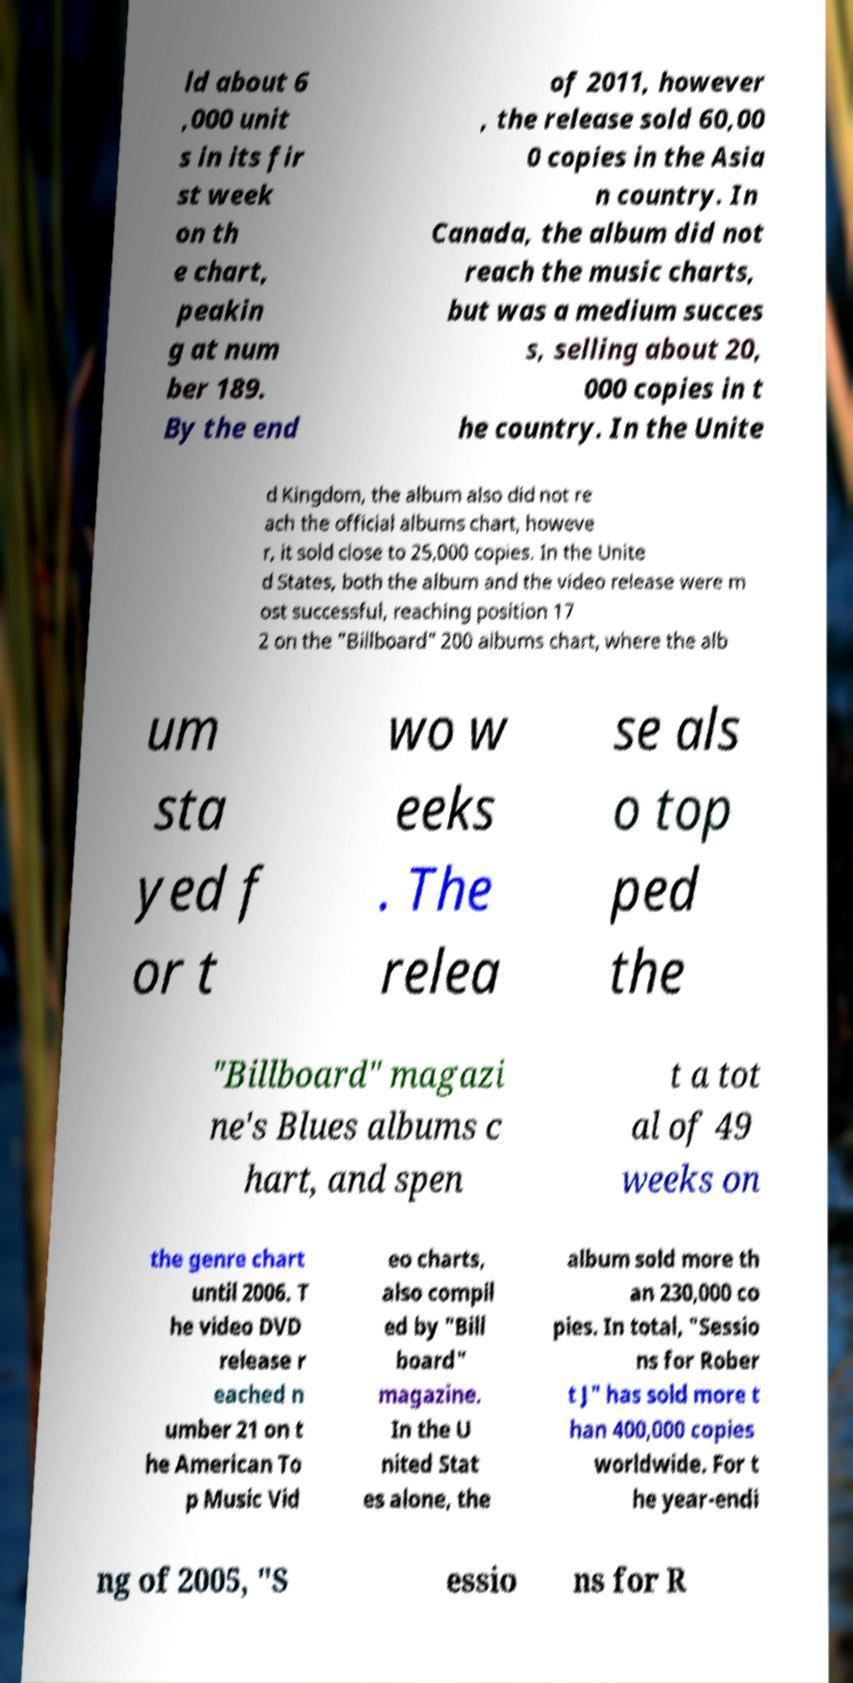Please read and relay the text visible in this image. What does it say? ld about 6 ,000 unit s in its fir st week on th e chart, peakin g at num ber 189. By the end of 2011, however , the release sold 60,00 0 copies in the Asia n country. In Canada, the album did not reach the music charts, but was a medium succes s, selling about 20, 000 copies in t he country. In the Unite d Kingdom, the album also did not re ach the official albums chart, howeve r, it sold close to 25,000 copies. In the Unite d States, both the album and the video release were m ost successful, reaching position 17 2 on the "Billboard" 200 albums chart, where the alb um sta yed f or t wo w eeks . The relea se als o top ped the "Billboard" magazi ne's Blues albums c hart, and spen t a tot al of 49 weeks on the genre chart until 2006. T he video DVD release r eached n umber 21 on t he American To p Music Vid eo charts, also compil ed by "Bill board" magazine. In the U nited Stat es alone, the album sold more th an 230,000 co pies. In total, "Sessio ns for Rober t J" has sold more t han 400,000 copies worldwide. For t he year-endi ng of 2005, "S essio ns for R 